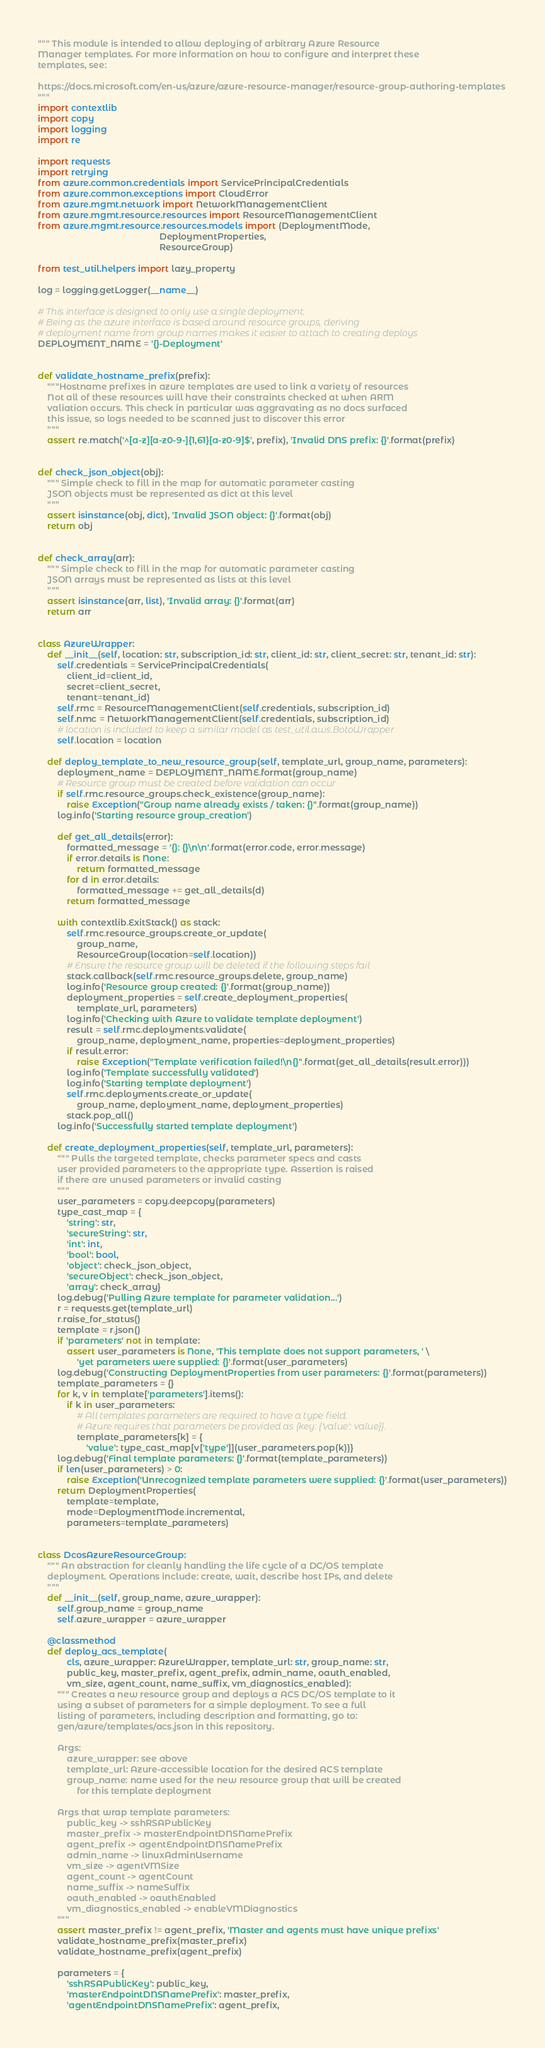<code> <loc_0><loc_0><loc_500><loc_500><_Python_>""" This module is intended to allow deploying of arbitrary Azure Resource
Manager templates. For more information on how to configure and interpret these
templates, see:

https://docs.microsoft.com/en-us/azure/azure-resource-manager/resource-group-authoring-templates
"""
import contextlib
import copy
import logging
import re

import requests
import retrying
from azure.common.credentials import ServicePrincipalCredentials
from azure.common.exceptions import CloudError
from azure.mgmt.network import NetworkManagementClient
from azure.mgmt.resource.resources import ResourceManagementClient
from azure.mgmt.resource.resources.models import (DeploymentMode,
                                                  DeploymentProperties,
                                                  ResourceGroup)

from test_util.helpers import lazy_property

log = logging.getLogger(__name__)

# This interface is designed to only use a single deployment.
# Being as the azure interface is based around resource groups, deriving
# deployment name from group names makes it easier to attach to creating deploys
DEPLOYMENT_NAME = '{}-Deployment'


def validate_hostname_prefix(prefix):
    """Hostname prefixes in azure templates are used to link a variety of resources
    Not all of these resources will have their constraints checked at when ARM
    valiation occurs. This check in particular was aggravating as no docs surfaced
    this issue, so logs needed to be scanned just to discover this error
    """
    assert re.match('^[a-z][a-z0-9-]{1,61}[a-z0-9]$', prefix), 'Invalid DNS prefix: {}'.format(prefix)


def check_json_object(obj):
    """ Simple check to fill in the map for automatic parameter casting
    JSON objects must be represented as dict at this level
    """
    assert isinstance(obj, dict), 'Invalid JSON object: {}'.format(obj)
    return obj


def check_array(arr):
    """ Simple check to fill in the map for automatic parameter casting
    JSON arrays must be represented as lists at this level
    """
    assert isinstance(arr, list), 'Invalid array: {}'.format(arr)
    return arr


class AzureWrapper:
    def __init__(self, location: str, subscription_id: str, client_id: str, client_secret: str, tenant_id: str):
        self.credentials = ServicePrincipalCredentials(
            client_id=client_id,
            secret=client_secret,
            tenant=tenant_id)
        self.rmc = ResourceManagementClient(self.credentials, subscription_id)
        self.nmc = NetworkManagementClient(self.credentials, subscription_id)
        # location is included to keep a similar model as test_util.aws.BotoWrapper
        self.location = location

    def deploy_template_to_new_resource_group(self, template_url, group_name, parameters):
        deployment_name = DEPLOYMENT_NAME.format(group_name)
        # Resource group must be created before validation can occur
        if self.rmc.resource_groups.check_existence(group_name):
            raise Exception("Group name already exists / taken: {}".format(group_name))
        log.info('Starting resource group_creation')

        def get_all_details(error):
            formatted_message = '{}: {}\n\n'.format(error.code, error.message)
            if error.details is None:
                return formatted_message
            for d in error.details:
                formatted_message += get_all_details(d)
            return formatted_message

        with contextlib.ExitStack() as stack:
            self.rmc.resource_groups.create_or_update(
                group_name,
                ResourceGroup(location=self.location))
            # Ensure the resource group will be deleted if the following steps fail
            stack.callback(self.rmc.resource_groups.delete, group_name)
            log.info('Resource group created: {}'.format(group_name))
            deployment_properties = self.create_deployment_properties(
                template_url, parameters)
            log.info('Checking with Azure to validate template deployment')
            result = self.rmc.deployments.validate(
                group_name, deployment_name, properties=deployment_properties)
            if result.error:
                raise Exception("Template verification failed!\n{}".format(get_all_details(result.error)))
            log.info('Template successfully validated')
            log.info('Starting template deployment')
            self.rmc.deployments.create_or_update(
                group_name, deployment_name, deployment_properties)
            stack.pop_all()
        log.info('Successfully started template deployment')

    def create_deployment_properties(self, template_url, parameters):
        """ Pulls the targeted template, checks parameter specs and casts
        user provided parameters to the appropriate type. Assertion is raised
        if there are unused parameters or invalid casting
        """
        user_parameters = copy.deepcopy(parameters)
        type_cast_map = {
            'string': str,
            'secureString': str,
            'int': int,
            'bool': bool,
            'object': check_json_object,
            'secureObject': check_json_object,
            'array': check_array}
        log.debug('Pulling Azure template for parameter validation...')
        r = requests.get(template_url)
        r.raise_for_status()
        template = r.json()
        if 'parameters' not in template:
            assert user_parameters is None, 'This template does not support parameters, ' \
                'yet parameters were supplied: {}'.format(user_parameters)
        log.debug('Constructing DeploymentProperties from user parameters: {}'.format(parameters))
        template_parameters = {}
        for k, v in template['parameters'].items():
            if k in user_parameters:
                # All templates parameters are required to have a type field.
                # Azure requires that parameters be provided as {key: {'value': value}}.
                template_parameters[k] = {
                    'value': type_cast_map[v['type']](user_parameters.pop(k))}
        log.debug('Final template parameters: {}'.format(template_parameters))
        if len(user_parameters) > 0:
            raise Exception('Unrecognized template parameters were supplied: {}'.format(user_parameters))
        return DeploymentProperties(
            template=template,
            mode=DeploymentMode.incremental,
            parameters=template_parameters)


class DcosAzureResourceGroup:
    """ An abstraction for cleanly handling the life cycle of a DC/OS template
    deployment. Operations include: create, wait, describe host IPs, and delete
    """
    def __init__(self, group_name, azure_wrapper):
        self.group_name = group_name
        self.azure_wrapper = azure_wrapper

    @classmethod
    def deploy_acs_template(
            cls, azure_wrapper: AzureWrapper, template_url: str, group_name: str,
            public_key, master_prefix, agent_prefix, admin_name, oauth_enabled,
            vm_size, agent_count, name_suffix, vm_diagnostics_enabled):
        """ Creates a new resource group and deploys a ACS DC/OS template to it
        using a subset of parameters for a simple deployment. To see a full
        listing of parameters, including description and formatting, go to:
        gen/azure/templates/acs.json in this repository.

        Args:
            azure_wrapper: see above
            template_url: Azure-accessible location for the desired ACS template
            group_name: name used for the new resource group that will be created
                for this template deployment

        Args that wrap template parameters:
            public_key -> sshRSAPublicKey
            master_prefix -> masterEndpointDNSNamePrefix
            agent_prefix -> agentEndpointDNSNamePrefix
            admin_name -> linuxAdminUsername
            vm_size -> agentVMSize
            agent_count -> agentCount
            name_suffix -> nameSuffix
            oauth_enabled -> oauthEnabled
            vm_diagnostics_enabled -> enableVMDiagnostics
        """
        assert master_prefix != agent_prefix, 'Master and agents must have unique prefixs'
        validate_hostname_prefix(master_prefix)
        validate_hostname_prefix(agent_prefix)

        parameters = {
            'sshRSAPublicKey': public_key,
            'masterEndpointDNSNamePrefix': master_prefix,
            'agentEndpointDNSNamePrefix': agent_prefix,</code> 